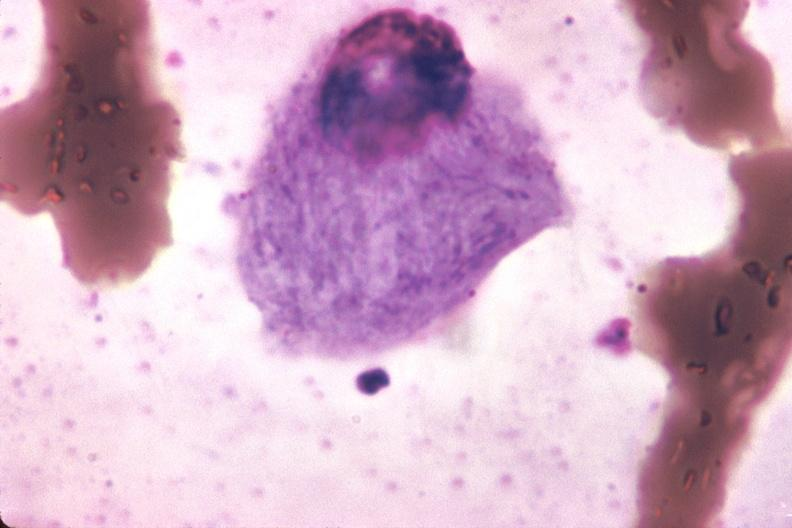s bone marrow present?
Answer the question using a single word or phrase. Yes 